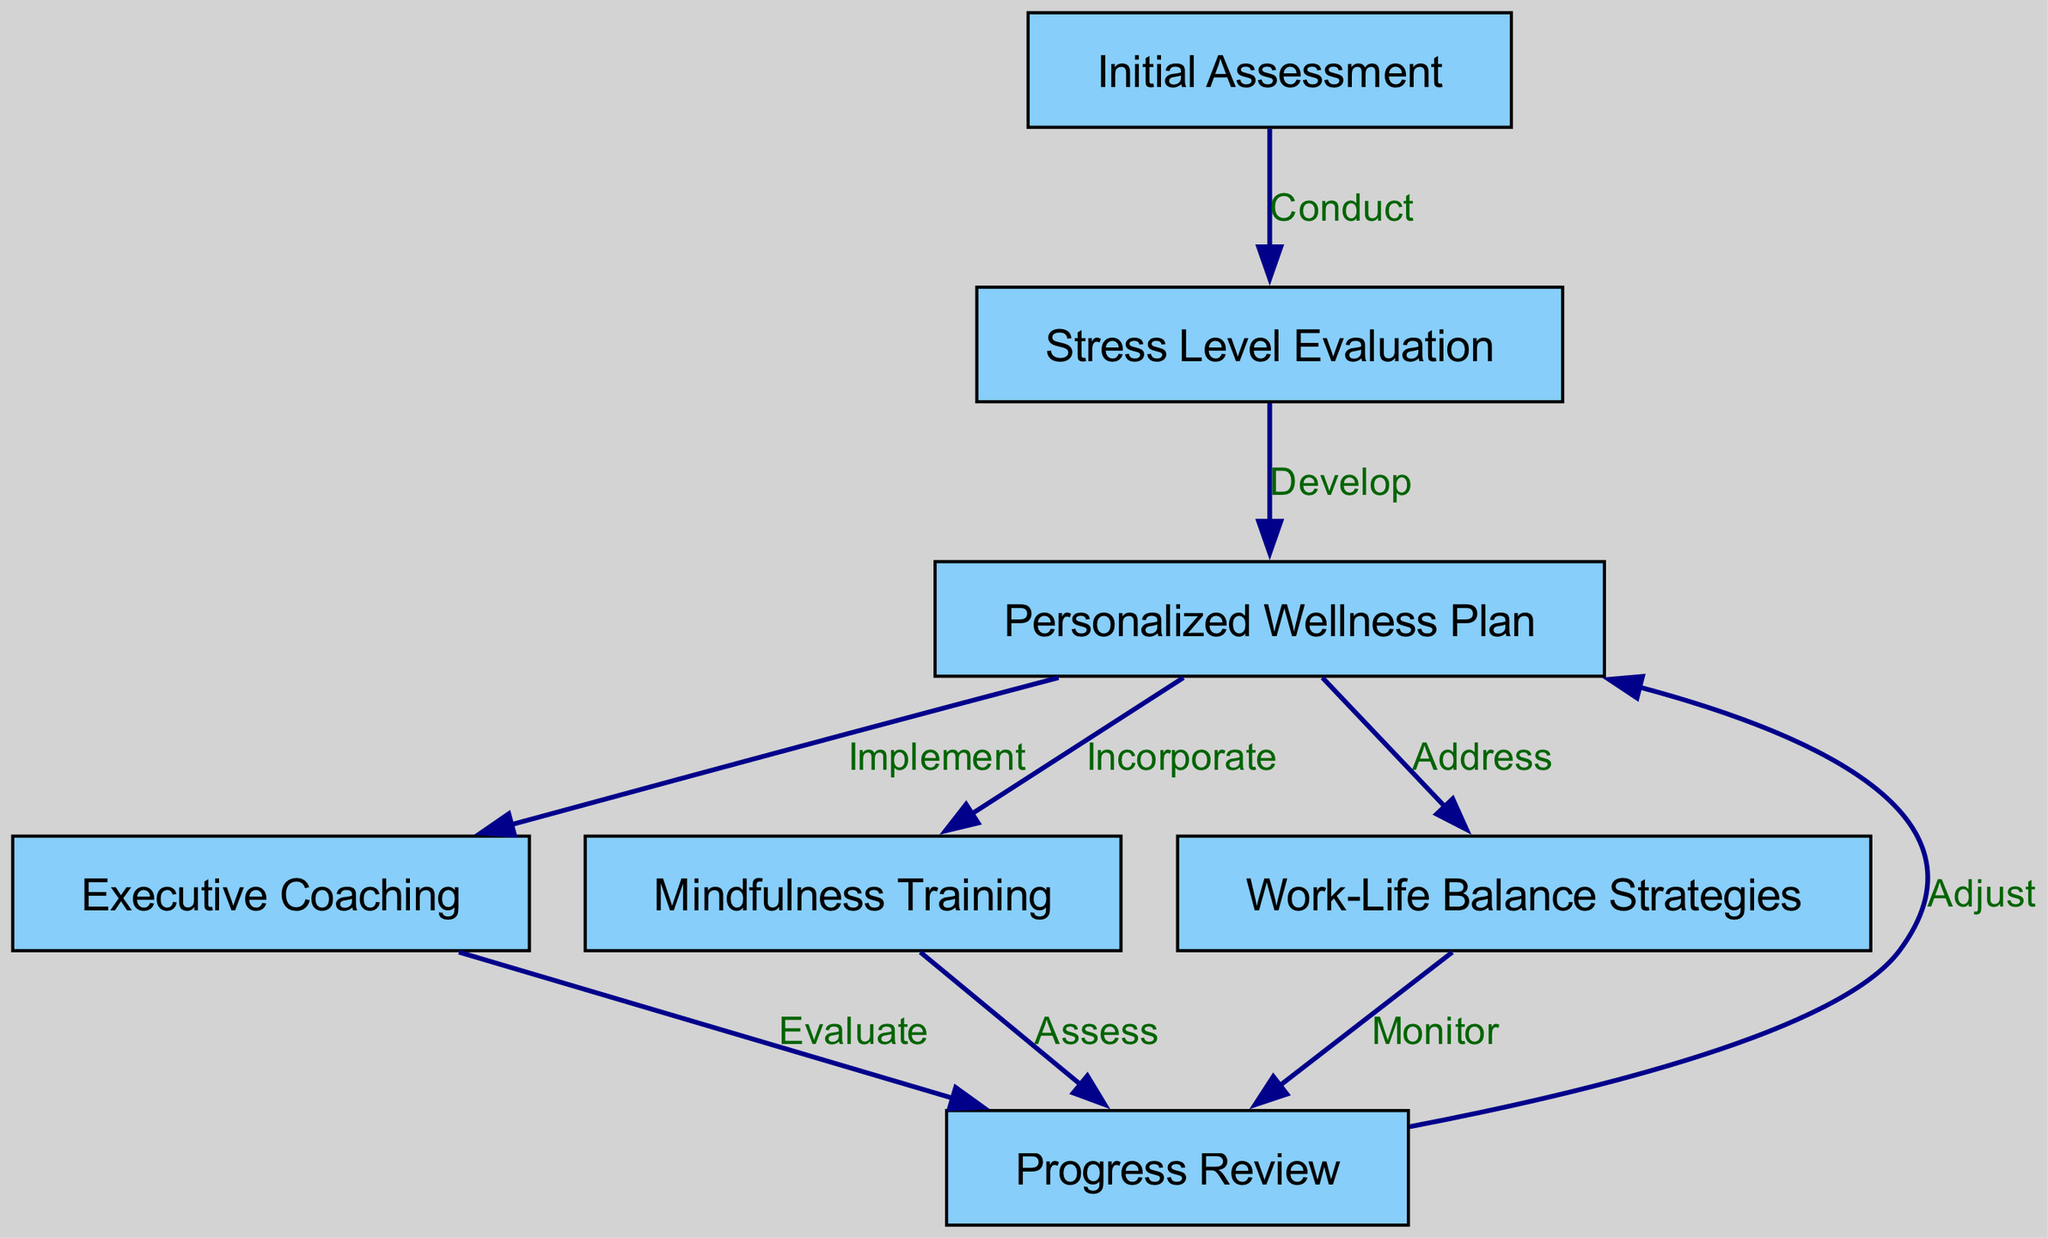What's the first step in the pathway? The first step is "Initial Assessment." This is identified as the starting node in the diagram.
Answer: Initial Assessment How many nodes are present in the diagram? By counting each of the individual nodes listed, there are seven nodes in total within the pathway.
Answer: 7 What is the last step before the "Progress Review"? The last step before reaching "Progress Review" is "Executive Coaching," which connects to "Progress Review" through an evaluative process.
Answer: Executive Coaching Which node incorporates "Mindfulness Training"? The node that incorporates "Mindfulness Training" is "Personalized Wellness Plan," as indicated by the directed edge connecting these two nodes.
Answer: Personalized Wellness Plan What action follows "Stress Level Evaluation"? The action that follows "Stress Level Evaluation" is "Develop," which leads to the creation of the "Personalized Wellness Plan."
Answer: Develop How many actions lead to the "Progress Review"? There are three actions that lead to the "Progress Review": "Evaluate," "Assess," and "Monitor." Each action corresponds to a different preceding node.
Answer: 3 What is the purpose of the "Initial Assessment"? The "Initial Assessment" serves to conduct an evaluation of the executive's current mental health and stress levels, setting the stage for subsequent steps.
Answer: Conduct Which nodes connect to the "Progress Review"? The nodes that connect to "Progress Review" are "Executive Coaching," "Mindfulness Training," and "Work-Life Balance Strategies," each providing inputs for evaluation.
Answer: Executive Coaching, Mindfulness Training, Work-Life Balance Strategies What happens after the "Progress Review"? After "Progress Review," the pathway leads back to "Personalized Wellness Plan," indicating a feedback loop for adjustments to the wellness plan based on the review findings.
Answer: Adjust 